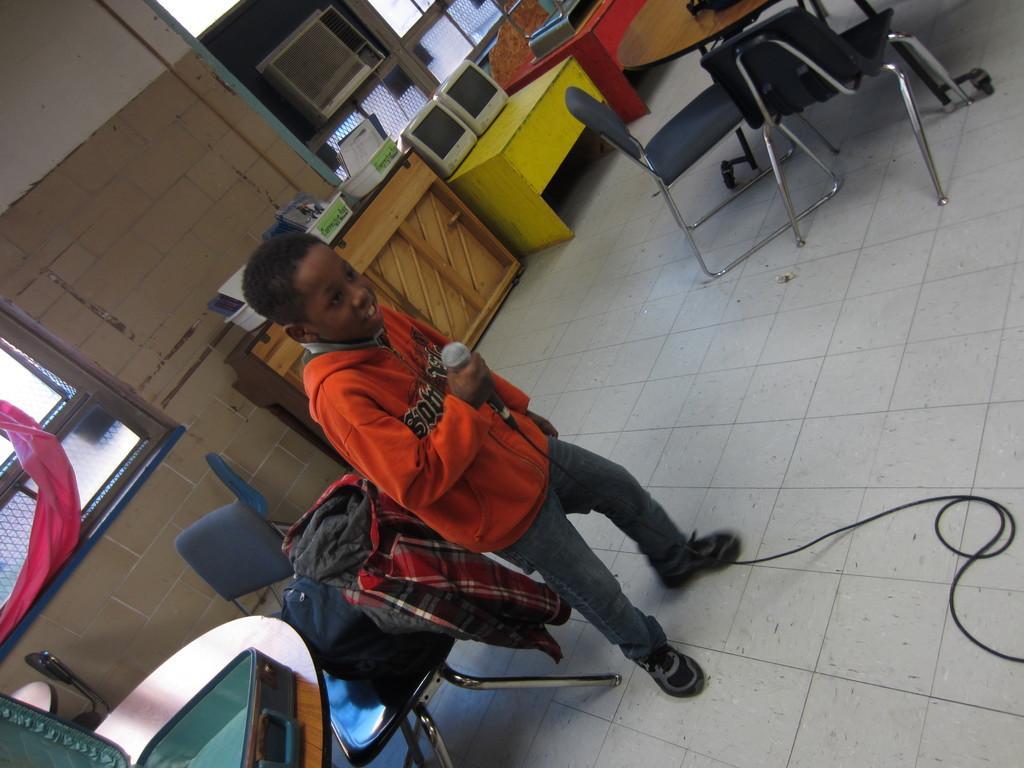Describe this image in one or two sentences. In this image there is a boy standing and holding a mike in his hand and at the back ground there is table, trolley , chair , jacket , monitors, table, containers or tray , window, air conditioner , another table and chairs. 